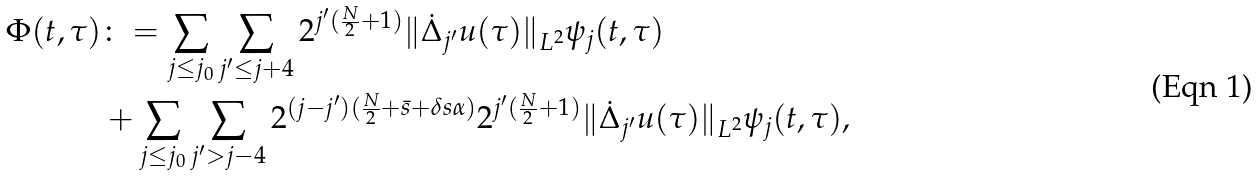Convert formula to latex. <formula><loc_0><loc_0><loc_500><loc_500>\Phi ( t , \tau ) & \colon = \sum _ { j \leq j _ { 0 } } \sum _ { j ^ { \prime } \leq j + 4 } 2 ^ { j ^ { \prime } ( \frac { N } { 2 } + 1 ) } \| \dot { \Delta } _ { j ^ { \prime } } u ( \tau ) \| _ { L ^ { 2 } } \psi _ { j } ( t , \tau ) \\ & + \sum _ { j \leq j _ { 0 } } \sum _ { j ^ { \prime } > j - 4 } 2 ^ { ( j - j ^ { \prime } ) ( \frac { N } { 2 } + \bar { s } + \delta s \alpha ) } 2 ^ { j ^ { \prime } ( \frac { N } { 2 } + 1 ) } \| \dot { \Delta } _ { j ^ { \prime } } u ( \tau ) \| _ { L ^ { 2 } } \psi _ { j } ( t , \tau ) ,</formula> 